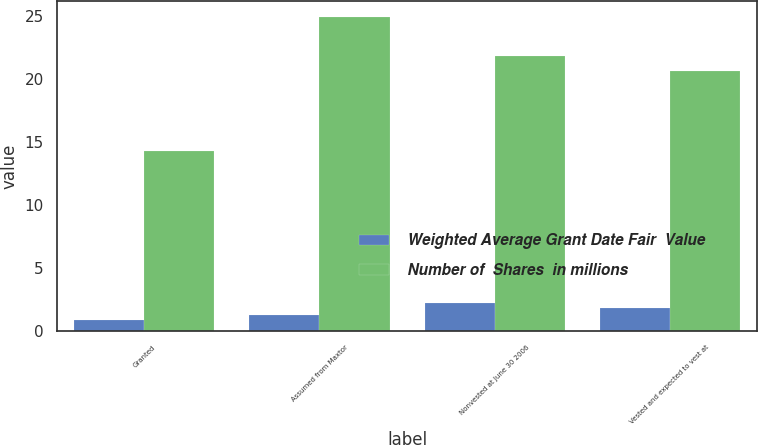Convert chart to OTSL. <chart><loc_0><loc_0><loc_500><loc_500><stacked_bar_chart><ecel><fcel>Granted<fcel>Assumed from Maxtor<fcel>Nonvested at June 30 2006<fcel>Vested and expected to vest at<nl><fcel>Weighted Average Grant Date Fair  Value<fcel>0.9<fcel>1.3<fcel>2.2<fcel>1.8<nl><fcel>Number of  Shares  in millions<fcel>14.28<fcel>24.95<fcel>21.84<fcel>20.65<nl></chart> 